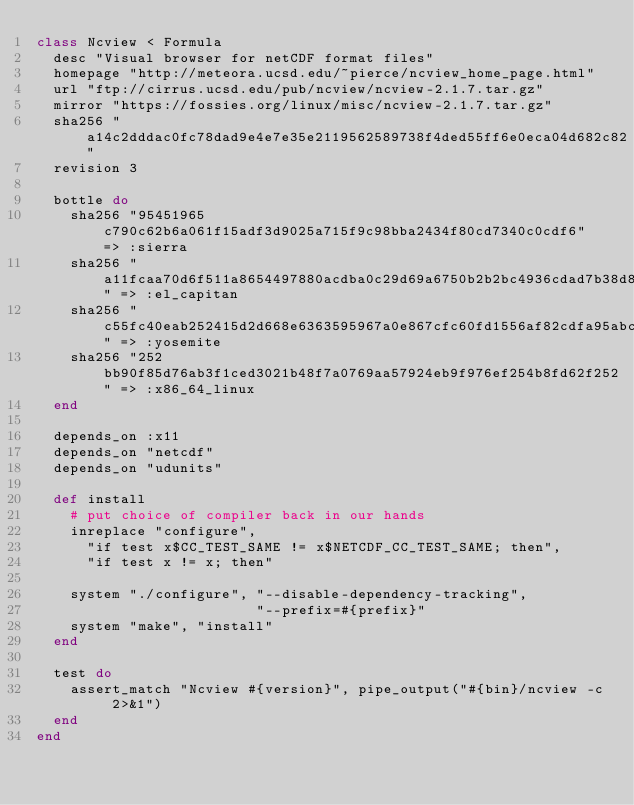Convert code to text. <code><loc_0><loc_0><loc_500><loc_500><_Ruby_>class Ncview < Formula
  desc "Visual browser for netCDF format files"
  homepage "http://meteora.ucsd.edu/~pierce/ncview_home_page.html"
  url "ftp://cirrus.ucsd.edu/pub/ncview/ncview-2.1.7.tar.gz"
  mirror "https://fossies.org/linux/misc/ncview-2.1.7.tar.gz"
  sha256 "a14c2dddac0fc78dad9e4e7e35e2119562589738f4ded55ff6e0eca04d682c82"
  revision 3

  bottle do
    sha256 "95451965c790c62b6a061f15adf3d9025a715f9c98bba2434f80cd7340c0cdf6" => :sierra
    sha256 "a11fcaa70d6f511a8654497880acdba0c29d69a6750b2b2bc4936cdad7b38d88" => :el_capitan
    sha256 "c55fc40eab252415d2d668e6363595967a0e867cfc60fd1556af82cdfa95abcd" => :yosemite
    sha256 "252bb90f85d76ab3f1ced3021b48f7a0769aa57924eb9f976ef254b8fd62f252" => :x86_64_linux
  end

  depends_on :x11
  depends_on "netcdf"
  depends_on "udunits"

  def install
    # put choice of compiler back in our hands
    inreplace "configure",
      "if test x$CC_TEST_SAME != x$NETCDF_CC_TEST_SAME; then",
      "if test x != x; then"

    system "./configure", "--disable-dependency-tracking",
                          "--prefix=#{prefix}"
    system "make", "install"
  end

  test do
    assert_match "Ncview #{version}", pipe_output("#{bin}/ncview -c 2>&1")
  end
end
</code> 